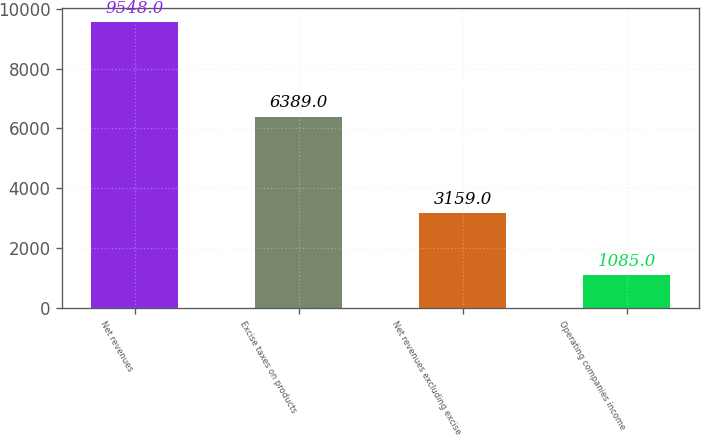<chart> <loc_0><loc_0><loc_500><loc_500><bar_chart><fcel>Net revenues<fcel>Excise taxes on products<fcel>Net revenues excluding excise<fcel>Operating companies income<nl><fcel>9548<fcel>6389<fcel>3159<fcel>1085<nl></chart> 